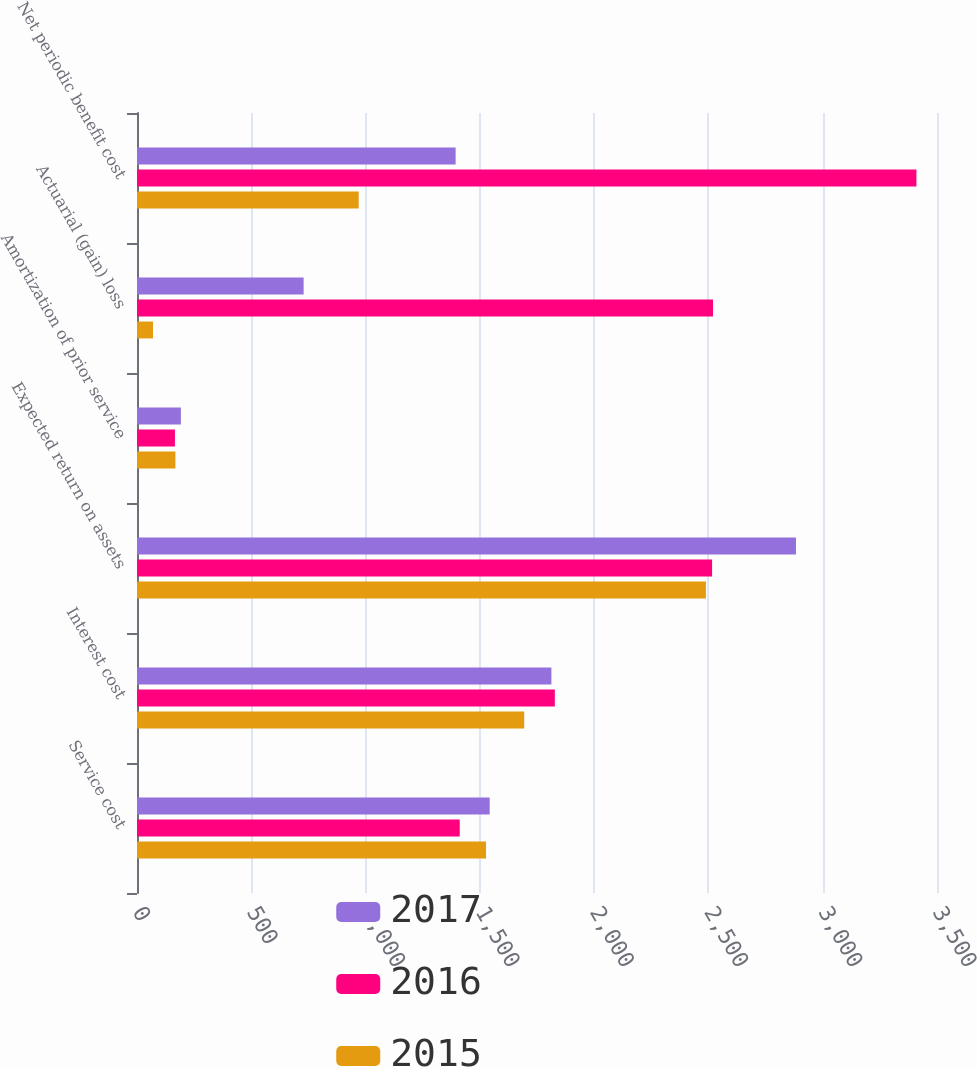Convert chart to OTSL. <chart><loc_0><loc_0><loc_500><loc_500><stacked_bar_chart><ecel><fcel>Service cost<fcel>Interest cost<fcel>Expected return on assets<fcel>Amortization of prior service<fcel>Actuarial (gain) loss<fcel>Net periodic benefit cost<nl><fcel>2017<fcel>1543<fcel>1813<fcel>2883<fcel>192<fcel>729<fcel>1394<nl><fcel>2016<fcel>1412<fcel>1828<fcel>2516<fcel>166<fcel>2520<fcel>3410<nl><fcel>2015<fcel>1527<fcel>1694<fcel>2489<fcel>168<fcel>70<fcel>970<nl></chart> 